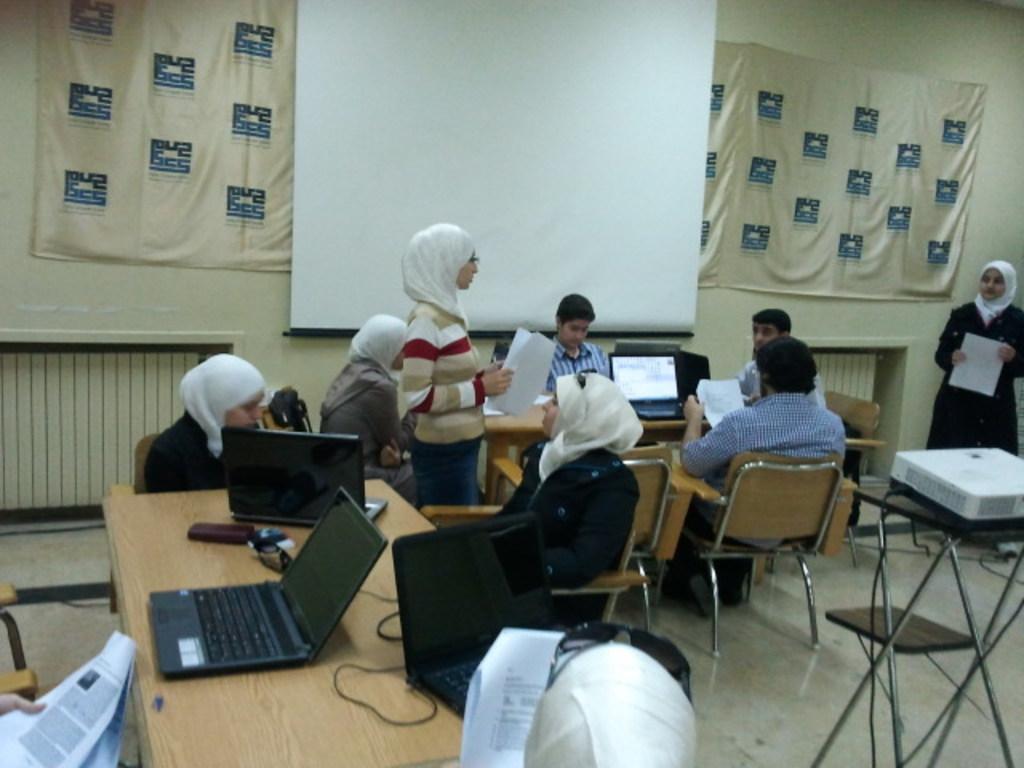In one or two sentences, can you explain what this image depicts? In this image I can see number of people where few of them are sitting on chairs and few are standing. Here I can see a white board. On these tables I can see few laptops. 